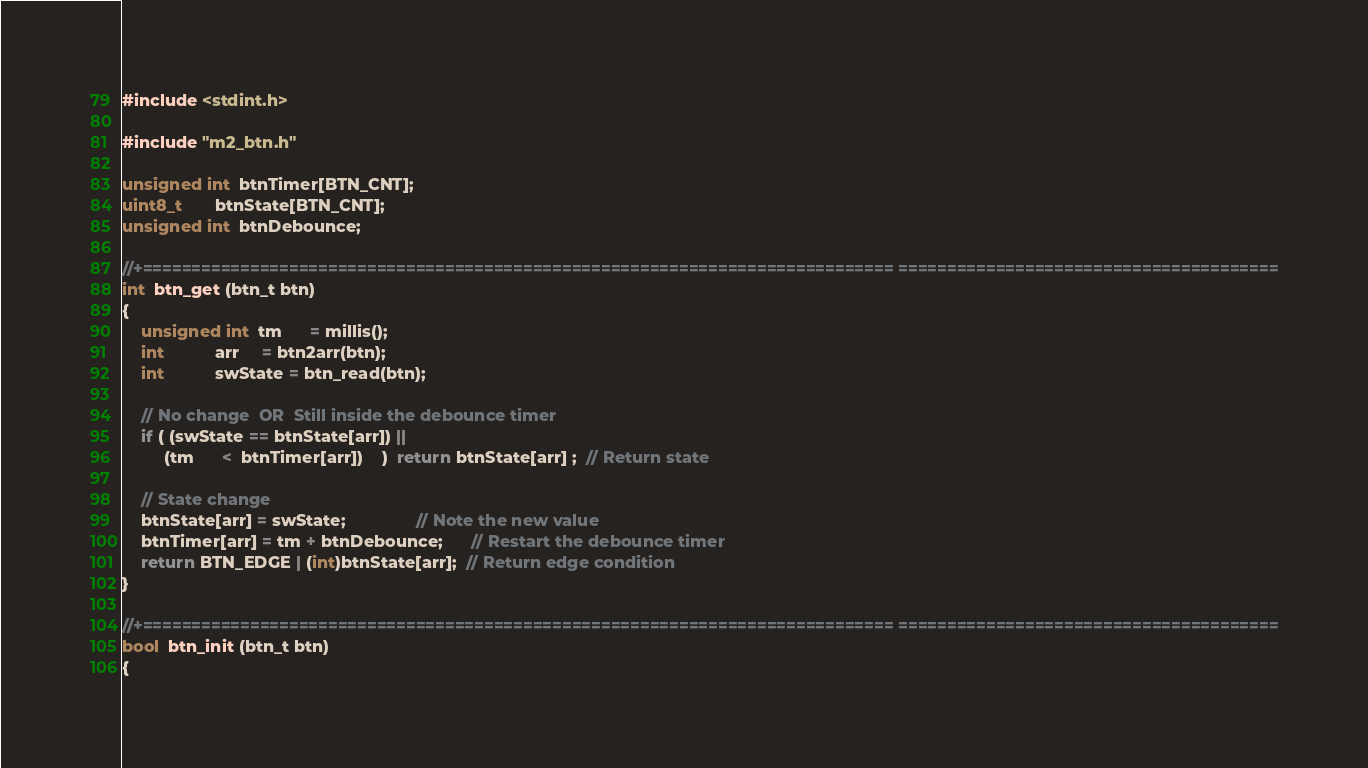<code> <loc_0><loc_0><loc_500><loc_500><_C++_>#include <stdint.h>

#include "m2_btn.h"
              
unsigned int  btnTimer[BTN_CNT];
uint8_t       btnState[BTN_CNT];
unsigned int  btnDebounce;

//+============================================================================= =======================================
int  btn_get (btn_t btn)
{
	unsigned int  tm      = millis();
	int           arr     = btn2arr(btn);
	int           swState = btn_read(btn);
	
	// No change  OR  Still inside the debounce timer
	if ( (swState == btnState[arr]) ||
	     (tm      <  btnTimer[arr])    )  return btnState[arr] ;  // Return state
	
	// State change
	btnState[arr] = swState;               // Note the new value
	btnTimer[arr] = tm + btnDebounce;      // Restart the debounce timer
	return BTN_EDGE | (int)btnState[arr];  // Return edge condition
}

//+============================================================================= =======================================
bool  btn_init (btn_t btn)
{</code> 